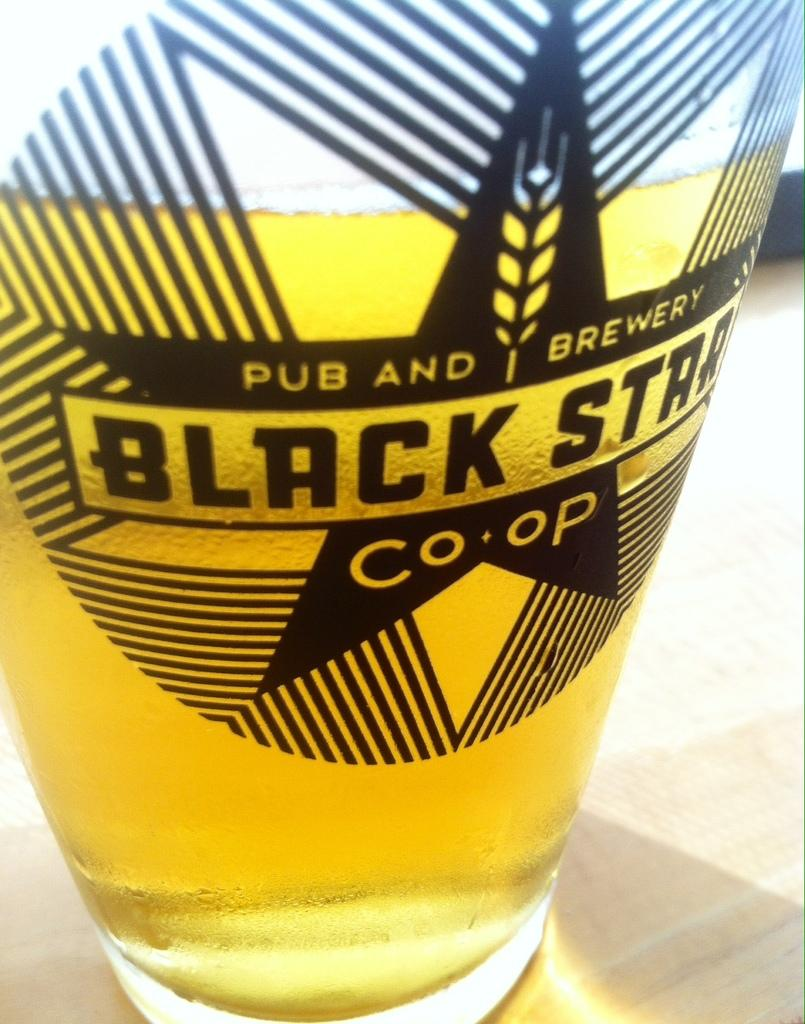<image>
Relay a brief, clear account of the picture shown. a beer cup that has the name co op written on it 